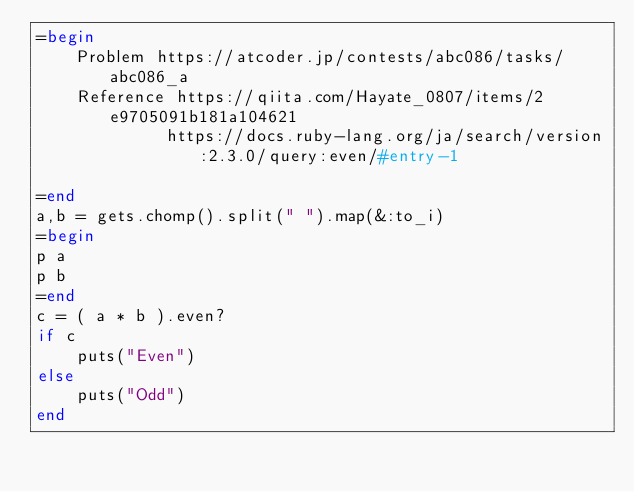<code> <loc_0><loc_0><loc_500><loc_500><_Ruby_>=begin
    Problem https://atcoder.jp/contests/abc086/tasks/abc086_a
    Reference https://qiita.com/Hayate_0807/items/2e9705091b181a104621
             https://docs.ruby-lang.org/ja/search/version:2.3.0/query:even/#entry-1

=end
a,b = gets.chomp().split(" ").map(&:to_i)
=begin
p a
p b
=end
c = ( a * b ).even?
if c
    puts("Even")
else
    puts("Odd")
end
</code> 